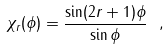Convert formula to latex. <formula><loc_0><loc_0><loc_500><loc_500>\chi _ { r } ( \phi ) = \frac { \sin ( 2 r + 1 ) \phi } { \sin \phi } \ ,</formula> 